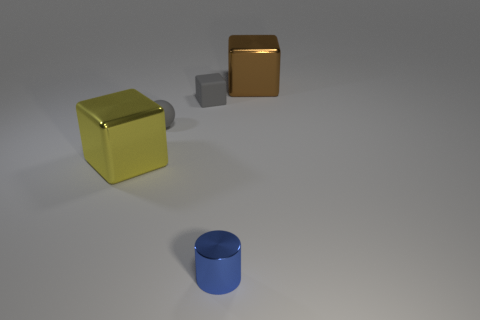Subtract all large yellow metallic cubes. How many cubes are left? 2 Add 2 big brown objects. How many objects exist? 7 Subtract all yellow blocks. How many blocks are left? 2 Subtract all spheres. How many objects are left? 4 Subtract 1 cubes. How many cubes are left? 2 Add 4 brown cubes. How many brown cubes are left? 5 Add 3 brown cubes. How many brown cubes exist? 4 Subtract 1 yellow cubes. How many objects are left? 4 Subtract all yellow spheres. Subtract all yellow blocks. How many spheres are left? 1 Subtract all tiny green shiny balls. Subtract all gray things. How many objects are left? 3 